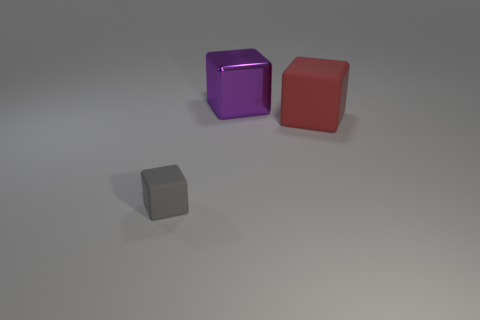There is a tiny gray thing that is the same shape as the big red rubber thing; what is it made of?
Ensure brevity in your answer.  Rubber. Are there any small purple metal things?
Offer a very short reply. No. Is there another small object that has the same material as the red thing?
Your answer should be compact. Yes. Do the big object in front of the purple object and the big purple cube have the same material?
Give a very brief answer. No. Is the number of red cubes in front of the purple cube greater than the number of big red cubes in front of the red object?
Offer a very short reply. Yes. What color is the other thing that is the same size as the red rubber object?
Provide a succinct answer. Purple. Are there any large rubber blocks of the same color as the big rubber object?
Give a very brief answer. No. There is a large purple cube that is on the left side of the red matte block; what is its material?
Your answer should be very brief. Metal. There is another object that is the same material as the large red object; what is its color?
Ensure brevity in your answer.  Gray. How many blue rubber things have the same size as the purple shiny block?
Make the answer very short. 0. 